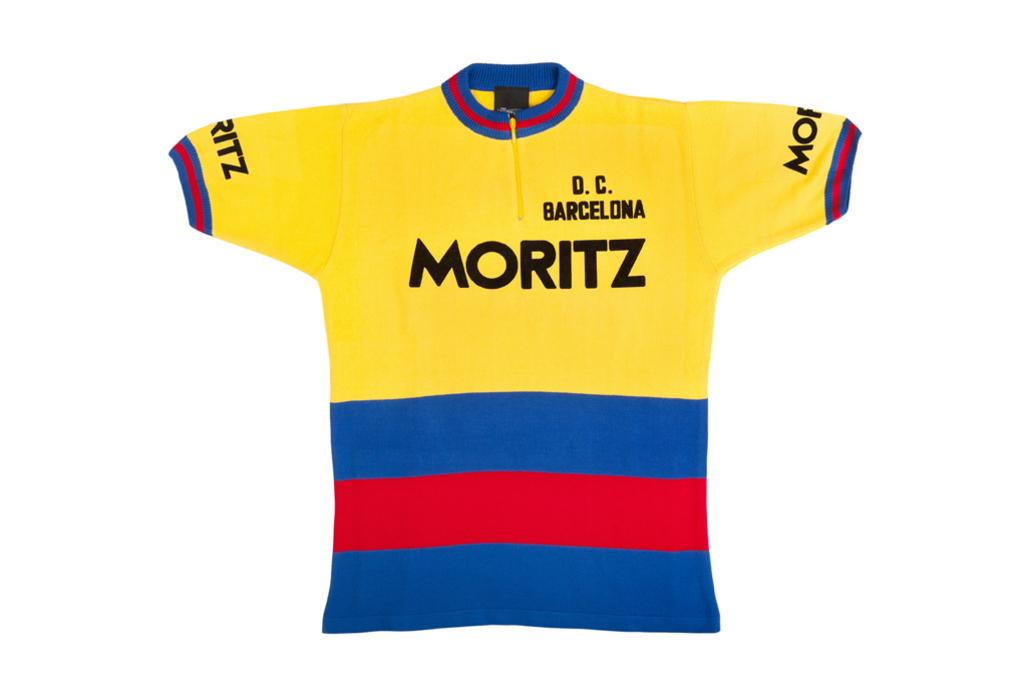<image>
Write a terse but informative summary of the picture. a yellow jersey with Moritz on it and D.C. Barcelona 